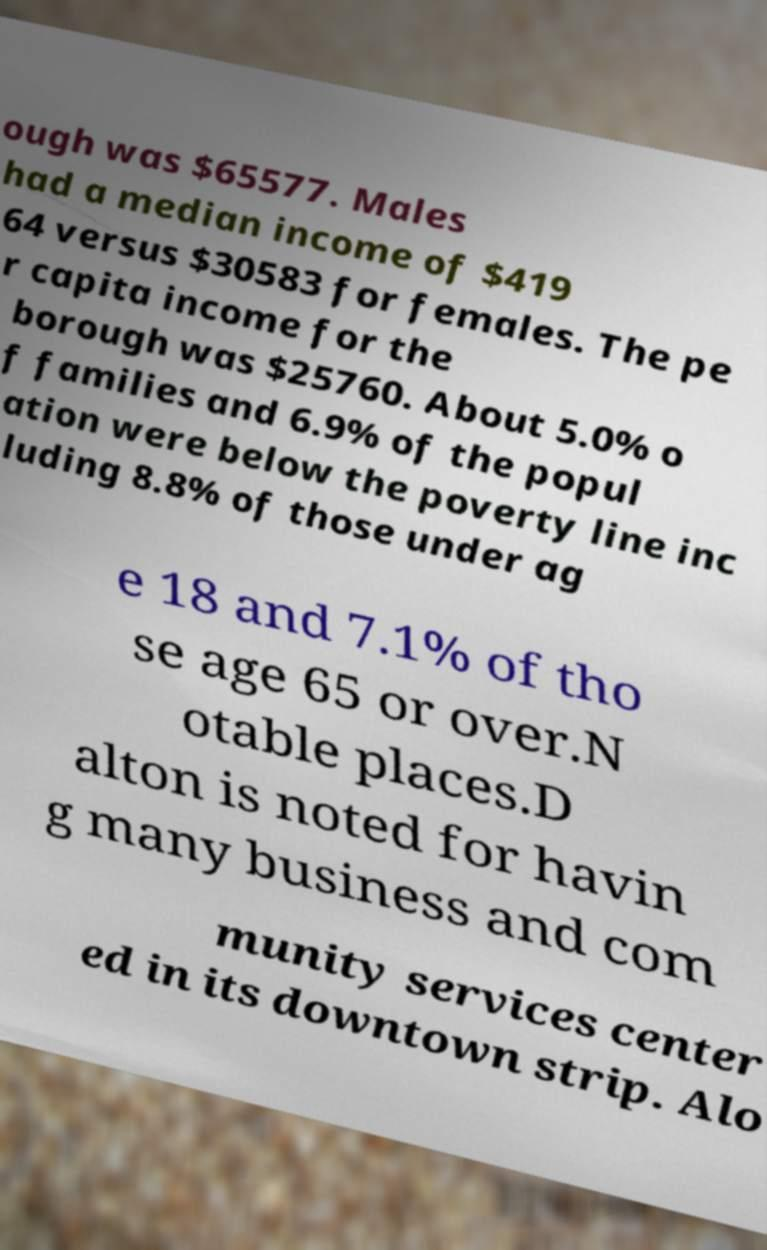Can you accurately transcribe the text from the provided image for me? ough was $65577. Males had a median income of $419 64 versus $30583 for females. The pe r capita income for the borough was $25760. About 5.0% o f families and 6.9% of the popul ation were below the poverty line inc luding 8.8% of those under ag e 18 and 7.1% of tho se age 65 or over.N otable places.D alton is noted for havin g many business and com munity services center ed in its downtown strip. Alo 